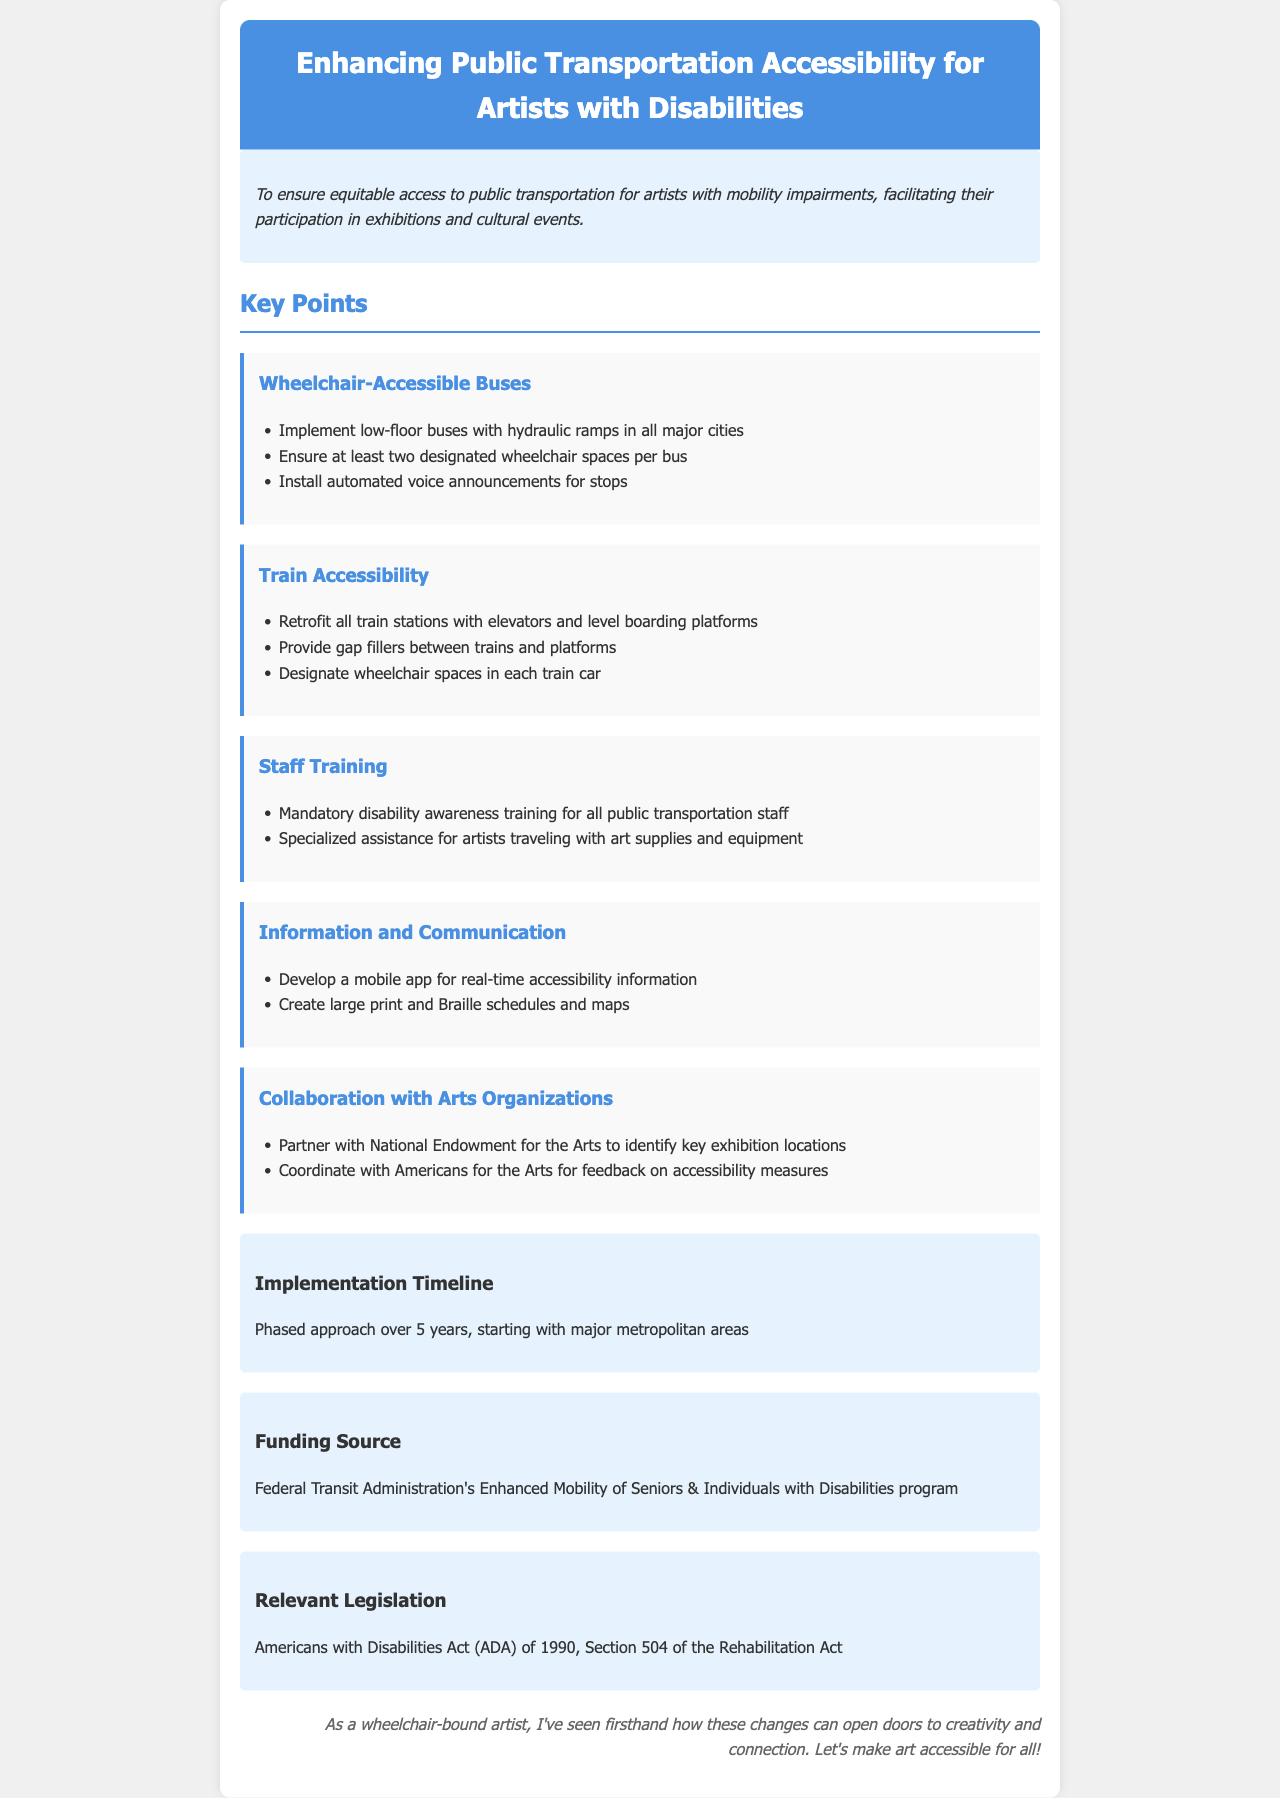What is the purpose of the document? The purpose of the document is outlined in the purpose section, which explains its aim to ensure equitable access to public transportation for artists with mobility impairments.
Answer: equitable access to public transportation for artists with mobility impairments How many designated wheelchair spaces are required per bus? The document states the specific requirement for wheelchair spaces on buses under the Wheelchair-Accessible Buses section.
Answer: two What is the key funding source mentioned? The funding source is provided in the funding section, which notes where financial support can be found.
Answer: Federal Transit Administration's Enhanced Mobility of Seniors & Individuals with Disabilities program What is the timeline for implementation? The implementation timeline provided in the document describes the planned approach and duration for changes.
Answer: 5 years Which act is relevant legislation mentioned in the document? The relevant legislation is discussed under the legislation section, naming the specific act that applies.
Answer: Americans with Disabilities Act (ADA) of 1990 What type of training is required for public transportation staff? The document specifies the kind of training mandated for staff in the Staff Training section.
Answer: disability awareness training What type of app is proposed in the document? The document specifies the purpose of the app being developed in the Information and Communication section.
Answer: mobile app for real-time accessibility information Which organizations are suggested for collaboration in the document? The document mentions the organizations to partner with in the Collaboration with Arts Organizations section.
Answer: National Endowment for the Arts and Americans for the Arts 